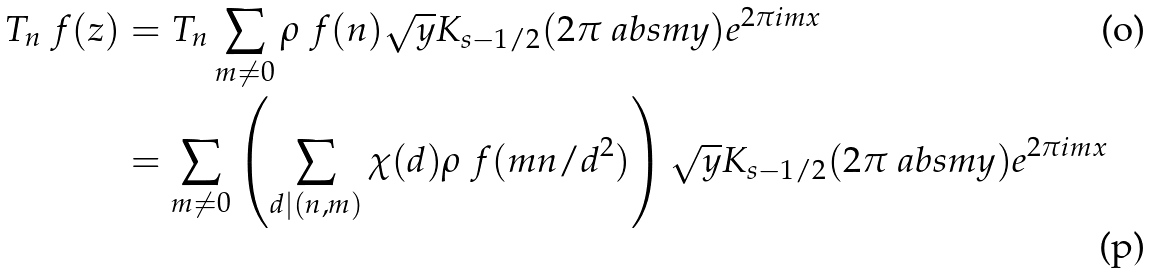Convert formula to latex. <formula><loc_0><loc_0><loc_500><loc_500>T _ { n } \ f ( z ) & = T _ { n } \sum _ { m \neq 0 } \rho _ { \ } f ( n ) \sqrt { y } K _ { s - 1 / 2 } ( 2 \pi \ a b s { m } y ) e ^ { 2 \pi i m x } \\ & = \sum _ { m \neq 0 } \left ( \sum _ { d | ( n , m ) } \chi ( d ) \rho _ { \ } f ( m n / d ^ { 2 } ) \right ) \sqrt { y } K _ { s - 1 / 2 } ( 2 \pi \ a b s { m } y ) e ^ { 2 \pi i m x }</formula> 